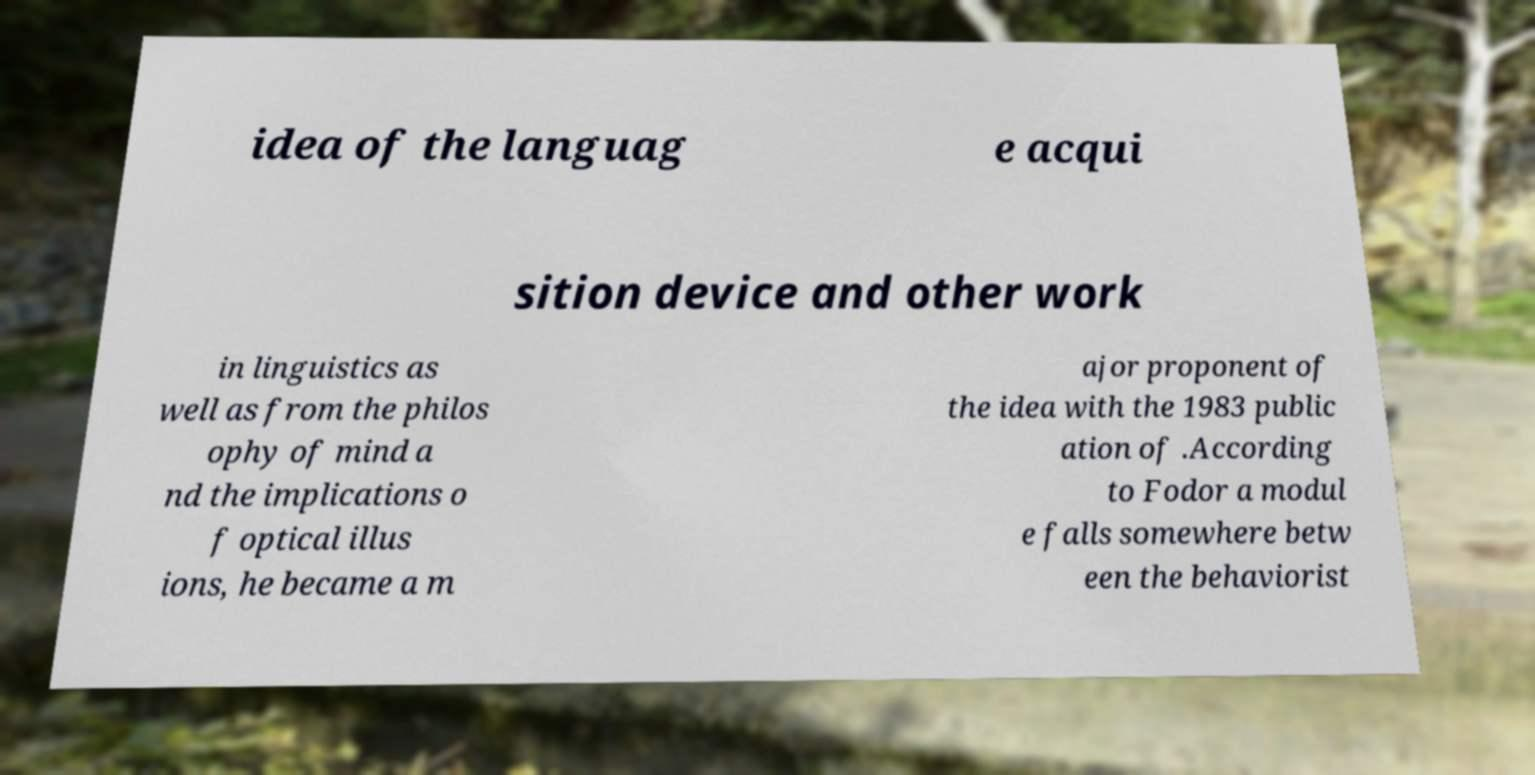Could you extract and type out the text from this image? idea of the languag e acqui sition device and other work in linguistics as well as from the philos ophy of mind a nd the implications o f optical illus ions, he became a m ajor proponent of the idea with the 1983 public ation of .According to Fodor a modul e falls somewhere betw een the behaviorist 